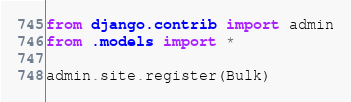Convert code to text. <code><loc_0><loc_0><loc_500><loc_500><_Python_>from django.contrib import admin
from .models import *

admin.site.register(Bulk)

</code> 